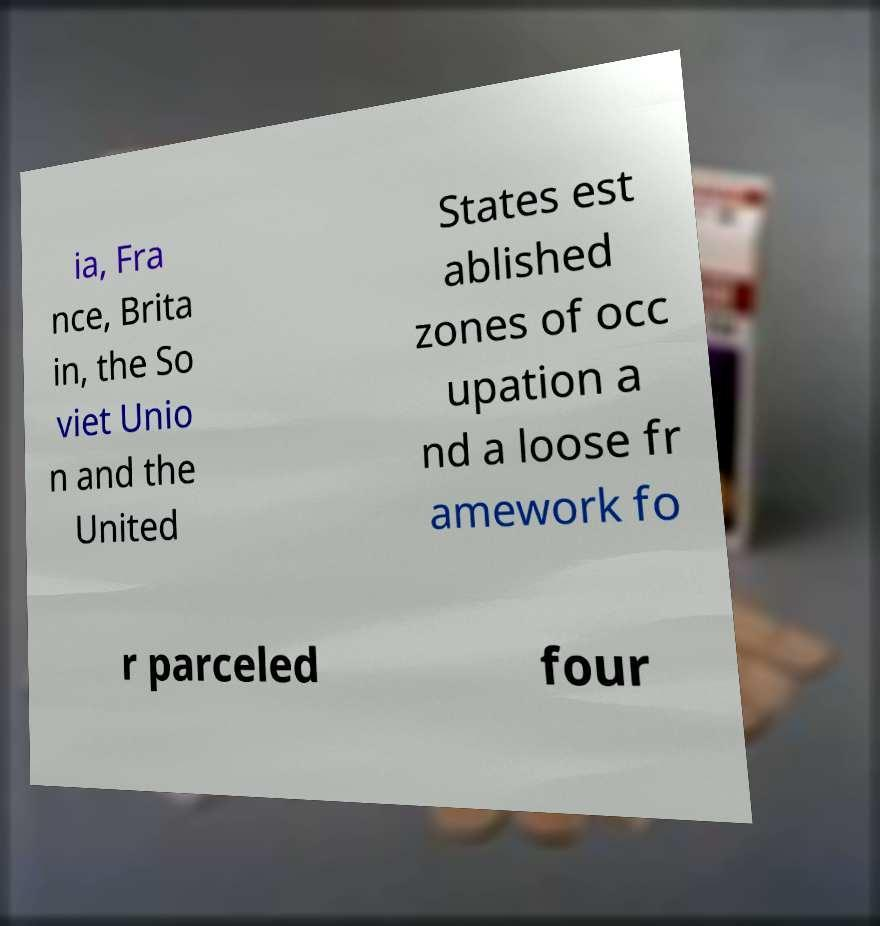There's text embedded in this image that I need extracted. Can you transcribe it verbatim? ia, Fra nce, Brita in, the So viet Unio n and the United States est ablished zones of occ upation a nd a loose fr amework fo r parceled four 